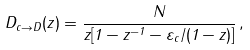<formula> <loc_0><loc_0><loc_500><loc_500>D _ { c \rightarrow D } ( z ) = \frac { N } { z [ 1 - z ^ { - 1 } - \varepsilon _ { c } / ( 1 - z ) ] } \, ,</formula> 